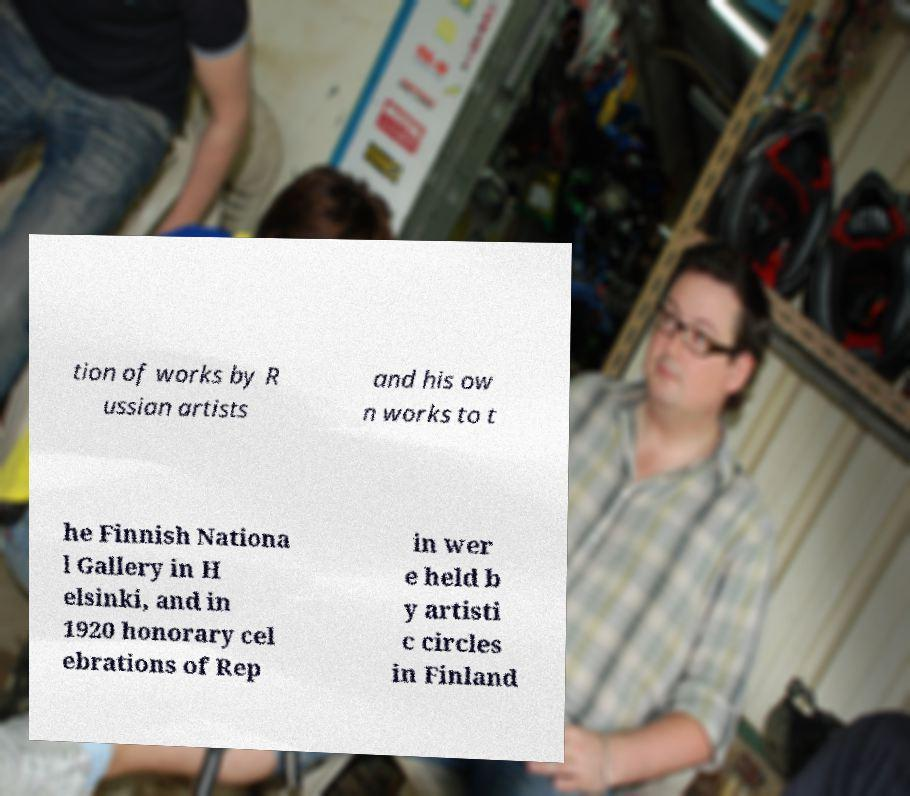For documentation purposes, I need the text within this image transcribed. Could you provide that? tion of works by R ussian artists and his ow n works to t he Finnish Nationa l Gallery in H elsinki, and in 1920 honorary cel ebrations of Rep in wer e held b y artisti c circles in Finland 